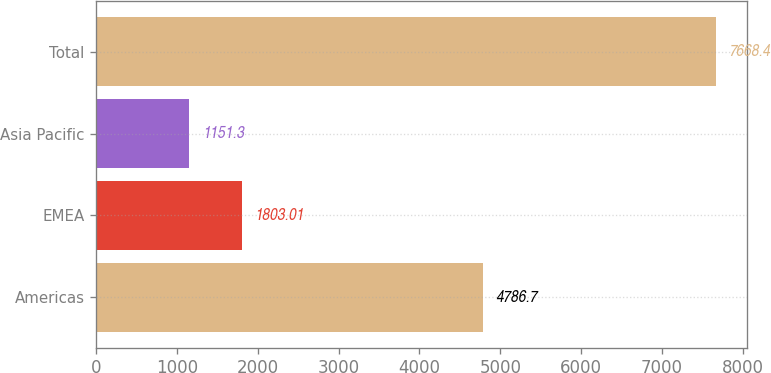<chart> <loc_0><loc_0><loc_500><loc_500><bar_chart><fcel>Americas<fcel>EMEA<fcel>Asia Pacific<fcel>Total<nl><fcel>4786.7<fcel>1803.01<fcel>1151.3<fcel>7668.4<nl></chart> 